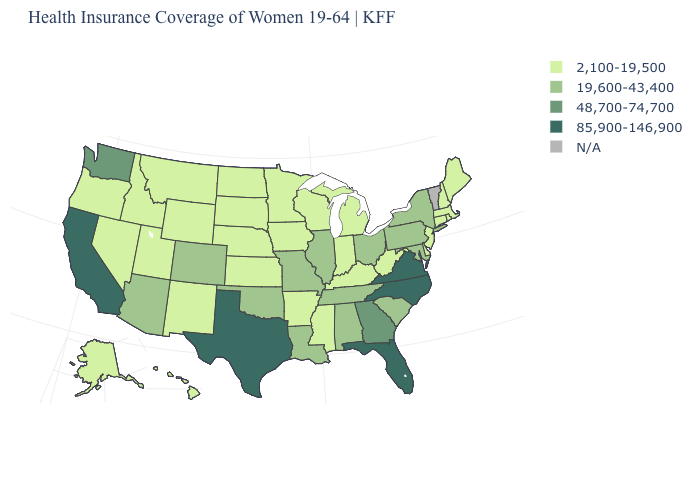Does Illinois have the highest value in the MidWest?
Give a very brief answer. Yes. What is the lowest value in the USA?
Answer briefly. 2,100-19,500. What is the value of Mississippi?
Concise answer only. 2,100-19,500. What is the value of Wyoming?
Be succinct. 2,100-19,500. What is the value of Utah?
Answer briefly. 2,100-19,500. Name the states that have a value in the range 2,100-19,500?
Keep it brief. Alaska, Arkansas, Connecticut, Delaware, Hawaii, Idaho, Indiana, Iowa, Kansas, Kentucky, Maine, Massachusetts, Michigan, Minnesota, Mississippi, Montana, Nebraska, Nevada, New Hampshire, New Jersey, New Mexico, North Dakota, Oregon, Rhode Island, South Dakota, Utah, West Virginia, Wisconsin, Wyoming. What is the highest value in the USA?
Short answer required. 85,900-146,900. What is the highest value in states that border Rhode Island?
Be succinct. 2,100-19,500. What is the value of Idaho?
Quick response, please. 2,100-19,500. Which states have the lowest value in the USA?
Concise answer only. Alaska, Arkansas, Connecticut, Delaware, Hawaii, Idaho, Indiana, Iowa, Kansas, Kentucky, Maine, Massachusetts, Michigan, Minnesota, Mississippi, Montana, Nebraska, Nevada, New Hampshire, New Jersey, New Mexico, North Dakota, Oregon, Rhode Island, South Dakota, Utah, West Virginia, Wisconsin, Wyoming. Name the states that have a value in the range 2,100-19,500?
Give a very brief answer. Alaska, Arkansas, Connecticut, Delaware, Hawaii, Idaho, Indiana, Iowa, Kansas, Kentucky, Maine, Massachusetts, Michigan, Minnesota, Mississippi, Montana, Nebraska, Nevada, New Hampshire, New Jersey, New Mexico, North Dakota, Oregon, Rhode Island, South Dakota, Utah, West Virginia, Wisconsin, Wyoming. Name the states that have a value in the range 48,700-74,700?
Quick response, please. Georgia, Washington. Name the states that have a value in the range 2,100-19,500?
Concise answer only. Alaska, Arkansas, Connecticut, Delaware, Hawaii, Idaho, Indiana, Iowa, Kansas, Kentucky, Maine, Massachusetts, Michigan, Minnesota, Mississippi, Montana, Nebraska, Nevada, New Hampshire, New Jersey, New Mexico, North Dakota, Oregon, Rhode Island, South Dakota, Utah, West Virginia, Wisconsin, Wyoming. What is the value of Texas?
Short answer required. 85,900-146,900. Does Florida have the lowest value in the South?
Write a very short answer. No. 